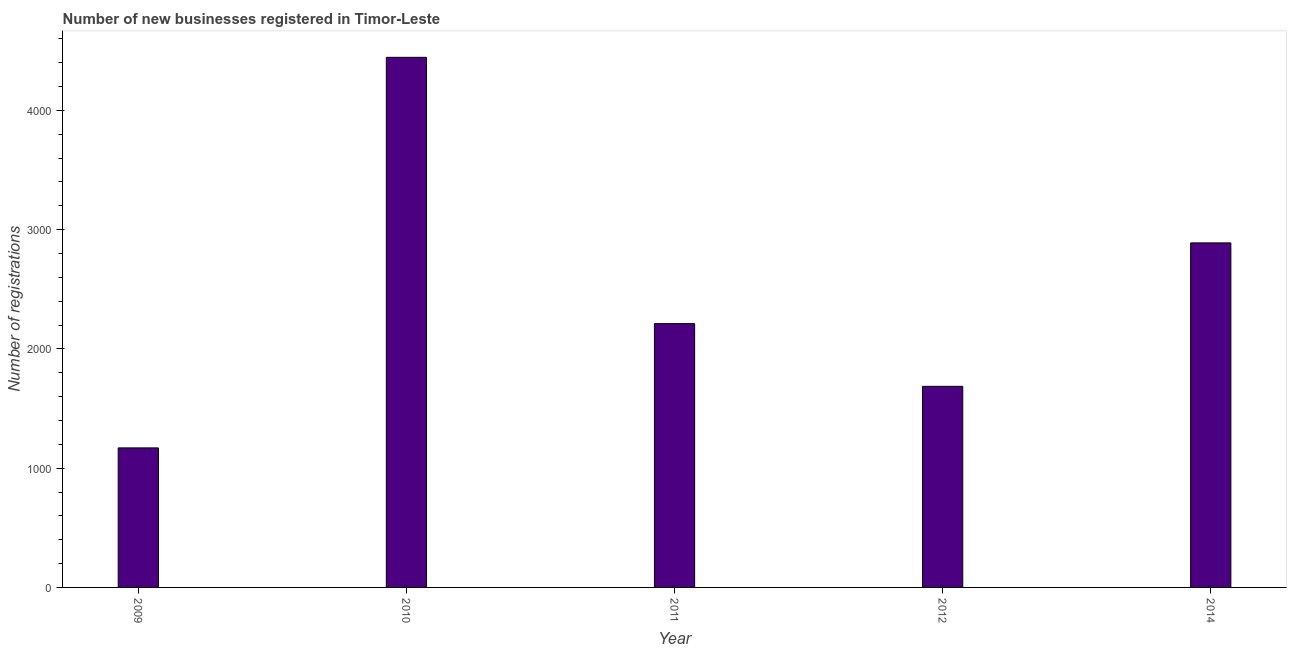What is the title of the graph?
Keep it short and to the point. Number of new businesses registered in Timor-Leste. What is the label or title of the X-axis?
Your answer should be compact. Year. What is the label or title of the Y-axis?
Your answer should be very brief. Number of registrations. What is the number of new business registrations in 2009?
Give a very brief answer. 1170. Across all years, what is the maximum number of new business registrations?
Your answer should be very brief. 4445. Across all years, what is the minimum number of new business registrations?
Offer a terse response. 1170. In which year was the number of new business registrations maximum?
Ensure brevity in your answer.  2010. In which year was the number of new business registrations minimum?
Your response must be concise. 2009. What is the sum of the number of new business registrations?
Your response must be concise. 1.24e+04. What is the difference between the number of new business registrations in 2011 and 2014?
Ensure brevity in your answer.  -677. What is the average number of new business registrations per year?
Your response must be concise. 2480. What is the median number of new business registrations?
Keep it short and to the point. 2212. In how many years, is the number of new business registrations greater than 2400 ?
Offer a very short reply. 2. Do a majority of the years between 2009 and 2011 (inclusive) have number of new business registrations greater than 4400 ?
Your answer should be very brief. No. What is the ratio of the number of new business registrations in 2011 to that in 2012?
Your answer should be very brief. 1.31. Is the number of new business registrations in 2009 less than that in 2012?
Your answer should be compact. Yes. What is the difference between the highest and the second highest number of new business registrations?
Ensure brevity in your answer.  1556. Is the sum of the number of new business registrations in 2009 and 2011 greater than the maximum number of new business registrations across all years?
Keep it short and to the point. No. What is the difference between the highest and the lowest number of new business registrations?
Keep it short and to the point. 3275. In how many years, is the number of new business registrations greater than the average number of new business registrations taken over all years?
Offer a very short reply. 2. Are all the bars in the graph horizontal?
Provide a short and direct response. No. Are the values on the major ticks of Y-axis written in scientific E-notation?
Keep it short and to the point. No. What is the Number of registrations of 2009?
Give a very brief answer. 1170. What is the Number of registrations in 2010?
Your answer should be compact. 4445. What is the Number of registrations of 2011?
Offer a very short reply. 2212. What is the Number of registrations in 2012?
Offer a very short reply. 1686. What is the Number of registrations of 2014?
Keep it short and to the point. 2889. What is the difference between the Number of registrations in 2009 and 2010?
Make the answer very short. -3275. What is the difference between the Number of registrations in 2009 and 2011?
Make the answer very short. -1042. What is the difference between the Number of registrations in 2009 and 2012?
Provide a short and direct response. -516. What is the difference between the Number of registrations in 2009 and 2014?
Make the answer very short. -1719. What is the difference between the Number of registrations in 2010 and 2011?
Provide a succinct answer. 2233. What is the difference between the Number of registrations in 2010 and 2012?
Your response must be concise. 2759. What is the difference between the Number of registrations in 2010 and 2014?
Your response must be concise. 1556. What is the difference between the Number of registrations in 2011 and 2012?
Provide a succinct answer. 526. What is the difference between the Number of registrations in 2011 and 2014?
Provide a short and direct response. -677. What is the difference between the Number of registrations in 2012 and 2014?
Give a very brief answer. -1203. What is the ratio of the Number of registrations in 2009 to that in 2010?
Your answer should be very brief. 0.26. What is the ratio of the Number of registrations in 2009 to that in 2011?
Offer a very short reply. 0.53. What is the ratio of the Number of registrations in 2009 to that in 2012?
Your answer should be very brief. 0.69. What is the ratio of the Number of registrations in 2009 to that in 2014?
Provide a succinct answer. 0.41. What is the ratio of the Number of registrations in 2010 to that in 2011?
Offer a very short reply. 2.01. What is the ratio of the Number of registrations in 2010 to that in 2012?
Your answer should be very brief. 2.64. What is the ratio of the Number of registrations in 2010 to that in 2014?
Your answer should be very brief. 1.54. What is the ratio of the Number of registrations in 2011 to that in 2012?
Keep it short and to the point. 1.31. What is the ratio of the Number of registrations in 2011 to that in 2014?
Provide a short and direct response. 0.77. What is the ratio of the Number of registrations in 2012 to that in 2014?
Your answer should be compact. 0.58. 